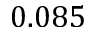Convert formula to latex. <formula><loc_0><loc_0><loc_500><loc_500>0 . 0 8 5</formula> 